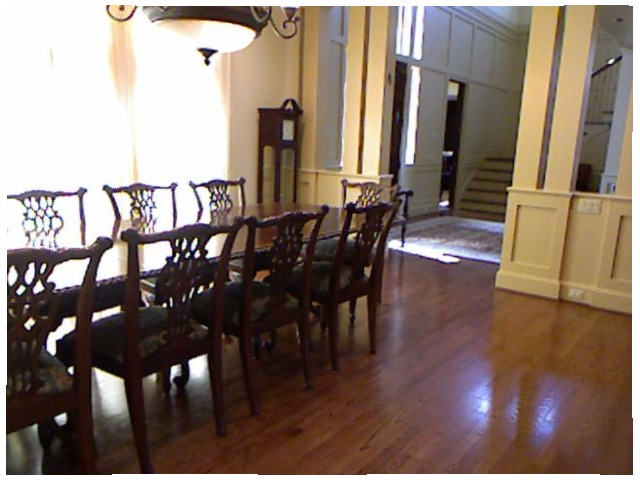<image>
Can you confirm if the chair is on the table? No. The chair is not positioned on the table. They may be near each other, but the chair is not supported by or resting on top of the table. Where is the chair in relation to the chair? Is it to the right of the chair? No. The chair is not to the right of the chair. The horizontal positioning shows a different relationship. 